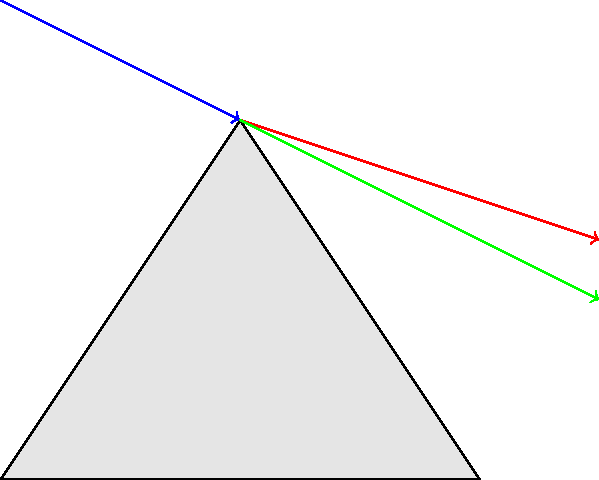In a children's science museum, there's an exhibit demonstrating how white light splits into different colors when passing through a prism. If you were explaining this to a child, which color would you say bends the most when passing through the prism, and why does this happen? Let's break this down step-by-step:

1. White light is actually made up of all the colors of the rainbow mixed together.

2. When white light enters a prism, it slows down and bends (refracts).

3. Different colors of light have different wavelengths. Red light has the longest wavelength, and violet light has the shortest wavelength among visible colors.

4. The amount of bending (refraction) depends on the wavelength of the light. Shorter wavelengths bend more than longer wavelengths.

5. This means that violet light, which has the shortest wavelength, bends the most when passing through the prism.

6. Red light, with the longest wavelength, bends the least.

7. This difference in bending separates the colors, creating a rainbow effect.

8. We can remember this by thinking of "ROY G BIV" (Red, Orange, Yellow, Green, Blue, Indigo, Violet) - the colors of the rainbow in order from least bent to most bent.

So, when explaining to a child, you would say that violet light bends the most because it has the shortest wavelength.
Answer: Violet light bends the most due to its shortest wavelength. 